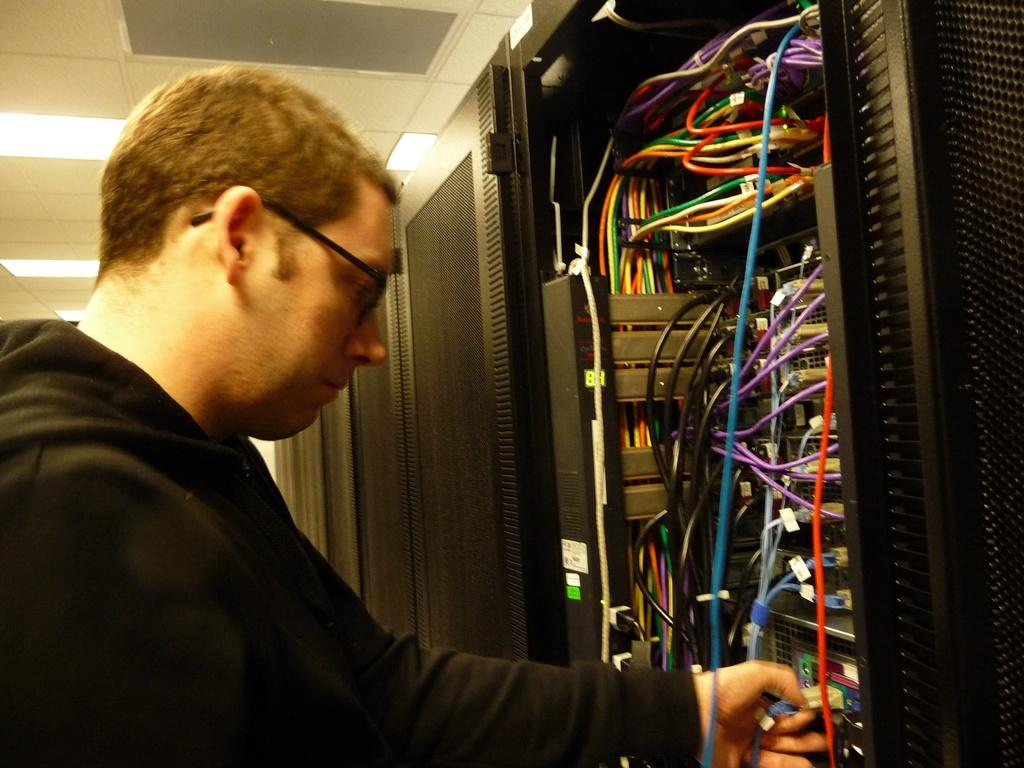What is the main subject of the image? There is a person in the image. What is the person wearing on their upper body? The person is wearing a black t-shirt. What accessory is the person wearing? The person is wearing spectacles. What can be seen in the background of the image? There are wires visible in the image, as well as black doors on the right side. What is present at the top of the image? There are lights at the top of the image. What type of sock is the crow wearing in the image? There is no crow or sock present in the image. What is the person doing on the earth in the image? The image does not show the person on the earth or performing any specific action. 